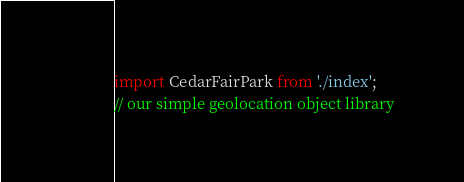<code> <loc_0><loc_0><loc_500><loc_500><_JavaScript_>import CedarFairPark from './index';
// our simple geolocation object library</code> 